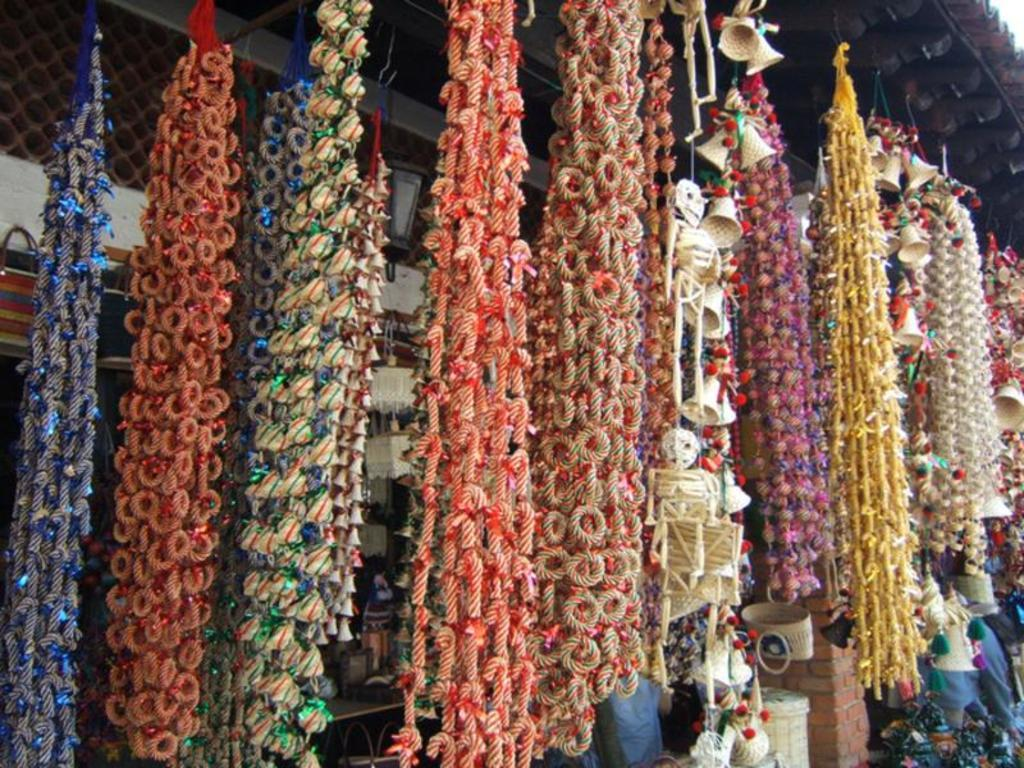What type of decorations can be seen in the image? There are decorations made with threads in the image. How are the decorations positioned? The decorations are hanging. What other objects can be seen in the image? There are baskets and racks in the image. What is the background of the image? There is a wall in the image, and a roof is visible at the top. Can you see any clouds in the image? There are no clouds visible in the image; it only shows decorations, baskets, racks, and a wall with a roof. Is there a slope in the image? There is no slope present in the image; it features a flat wall and roof. 